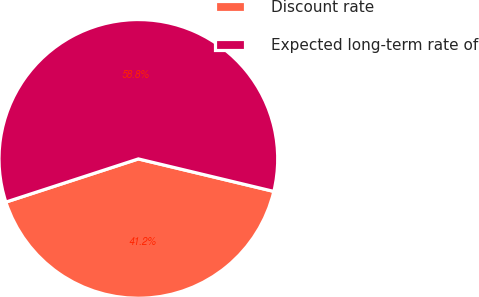<chart> <loc_0><loc_0><loc_500><loc_500><pie_chart><fcel>Discount rate<fcel>Expected long-term rate of<nl><fcel>41.24%<fcel>58.76%<nl></chart> 